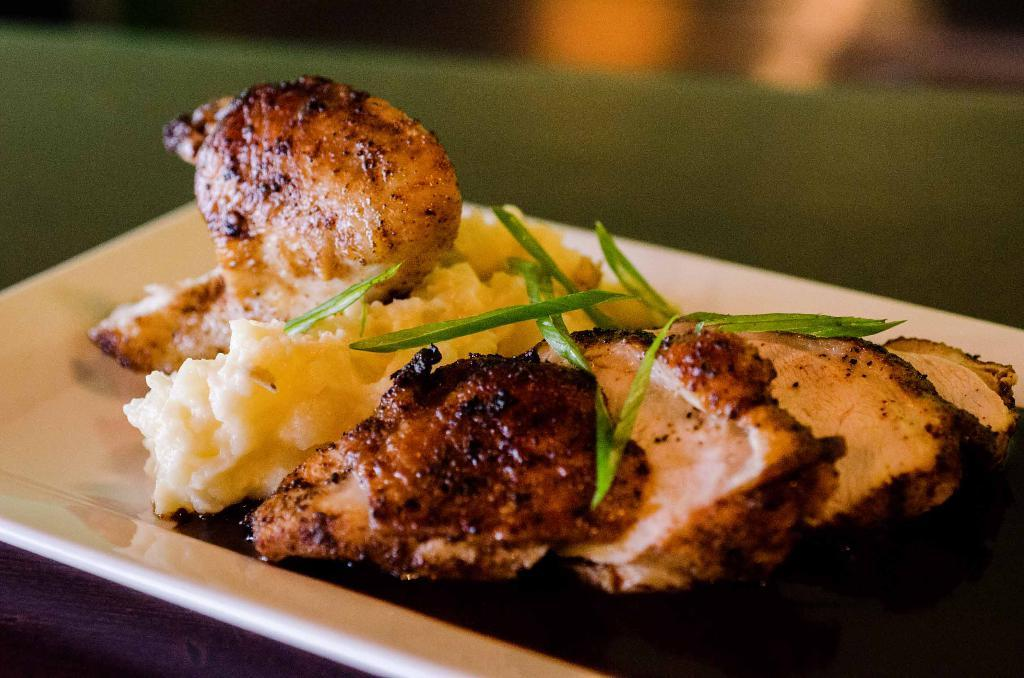What is on the plate that is visible in the image? There is food on a plate in the image. Where is the plate located in the image? The plate is placed on a table in the image. What type of songs can be heard being sung by the pets in the image? There are no pets or songs present in the image; it only features a plate of food on a table. 